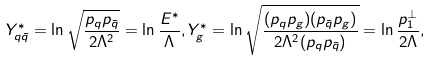Convert formula to latex. <formula><loc_0><loc_0><loc_500><loc_500>Y ^ { * } _ { q \bar { q } } = \ln \sqrt { \frac { p _ { q } p _ { \bar { q } } } { 2 \Lambda ^ { 2 } } } = \ln \frac { E ^ { * } } { \Lambda } , Y ^ { * } _ { g } = \ln \sqrt { \frac { ( p _ { q } p _ { g } ) ( p _ { \bar { q } } p _ { g } ) } { 2 \Lambda ^ { 2 } ( p _ { q } p _ { \bar { q } } ) } } = \ln \frac { p _ { 1 } ^ { \perp } } { 2 \Lambda } ,</formula> 